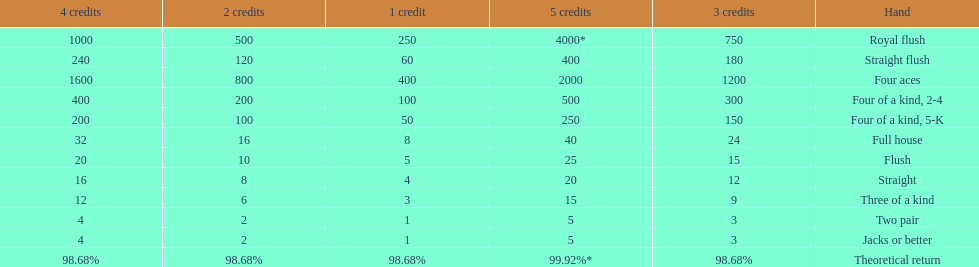At most, what could a person earn for having a full house? 40. Parse the full table. {'header': ['4 credits', '2 credits', '1 credit', '5 credits', '3 credits', 'Hand'], 'rows': [['1000', '500', '250', '4000*', '750', 'Royal flush'], ['240', '120', '60', '400', '180', 'Straight flush'], ['1600', '800', '400', '2000', '1200', 'Four aces'], ['400', '200', '100', '500', '300', 'Four of a kind, 2-4'], ['200', '100', '50', '250', '150', 'Four of a kind, 5-K'], ['32', '16', '8', '40', '24', 'Full house'], ['20', '10', '5', '25', '15', 'Flush'], ['16', '8', '4', '20', '12', 'Straight'], ['12', '6', '3', '15', '9', 'Three of a kind'], ['4', '2', '1', '5', '3', 'Two pair'], ['4', '2', '1', '5', '3', 'Jacks or better'], ['98.68%', '98.68%', '98.68%', '99.92%*', '98.68%', 'Theoretical return']]} 